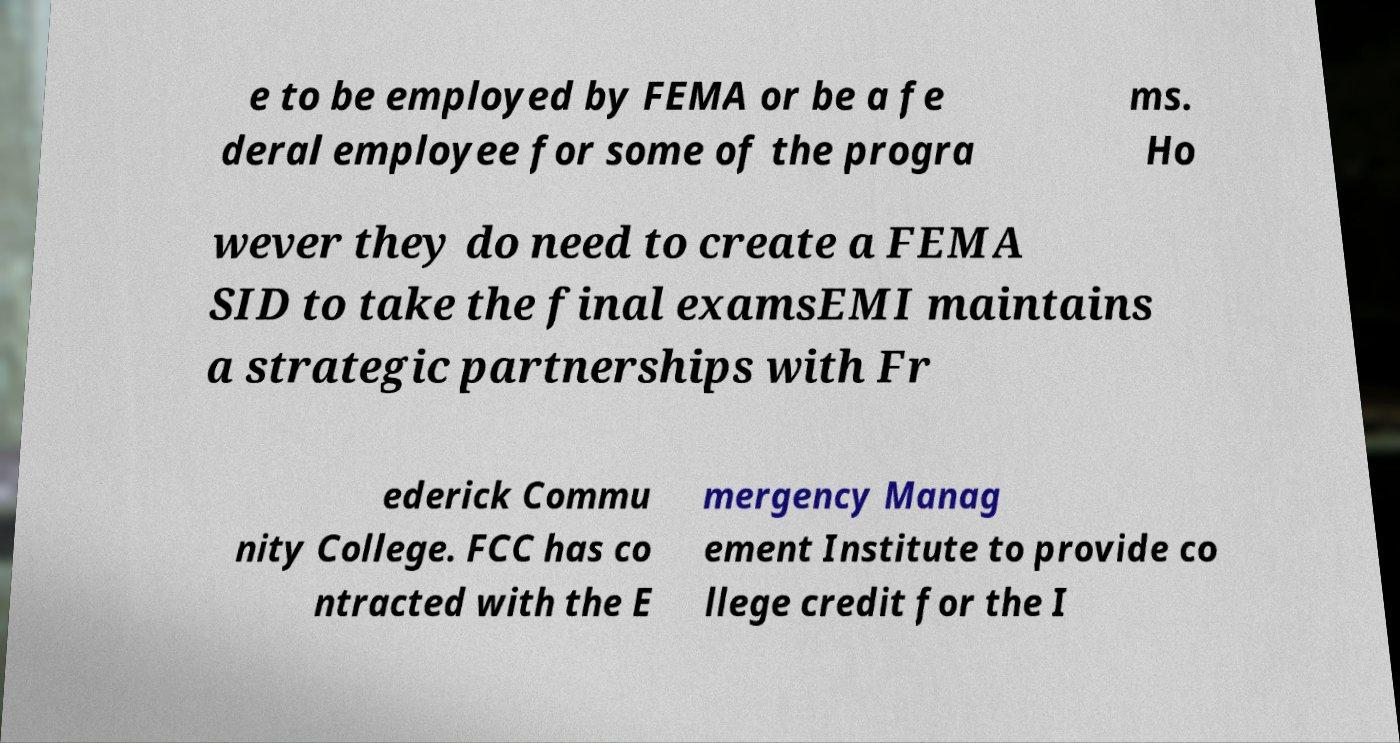I need the written content from this picture converted into text. Can you do that? e to be employed by FEMA or be a fe deral employee for some of the progra ms. Ho wever they do need to create a FEMA SID to take the final examsEMI maintains a strategic partnerships with Fr ederick Commu nity College. FCC has co ntracted with the E mergency Manag ement Institute to provide co llege credit for the I 